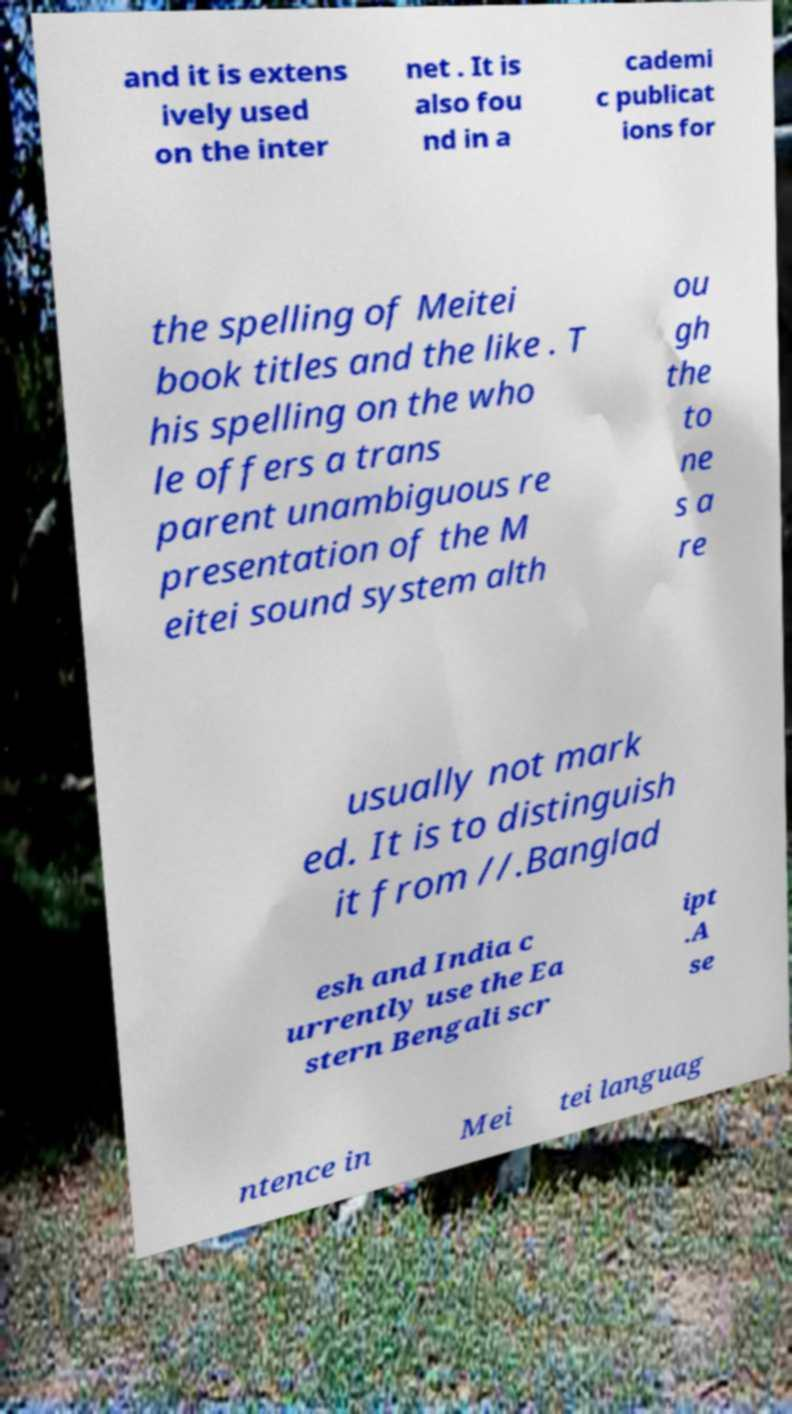For documentation purposes, I need the text within this image transcribed. Could you provide that? and it is extens ively used on the inter net . It is also fou nd in a cademi c publicat ions for the spelling of Meitei book titles and the like . T his spelling on the who le offers a trans parent unambiguous re presentation of the M eitei sound system alth ou gh the to ne s a re usually not mark ed. It is to distinguish it from //.Banglad esh and India c urrently use the Ea stern Bengali scr ipt .A se ntence in Mei tei languag 